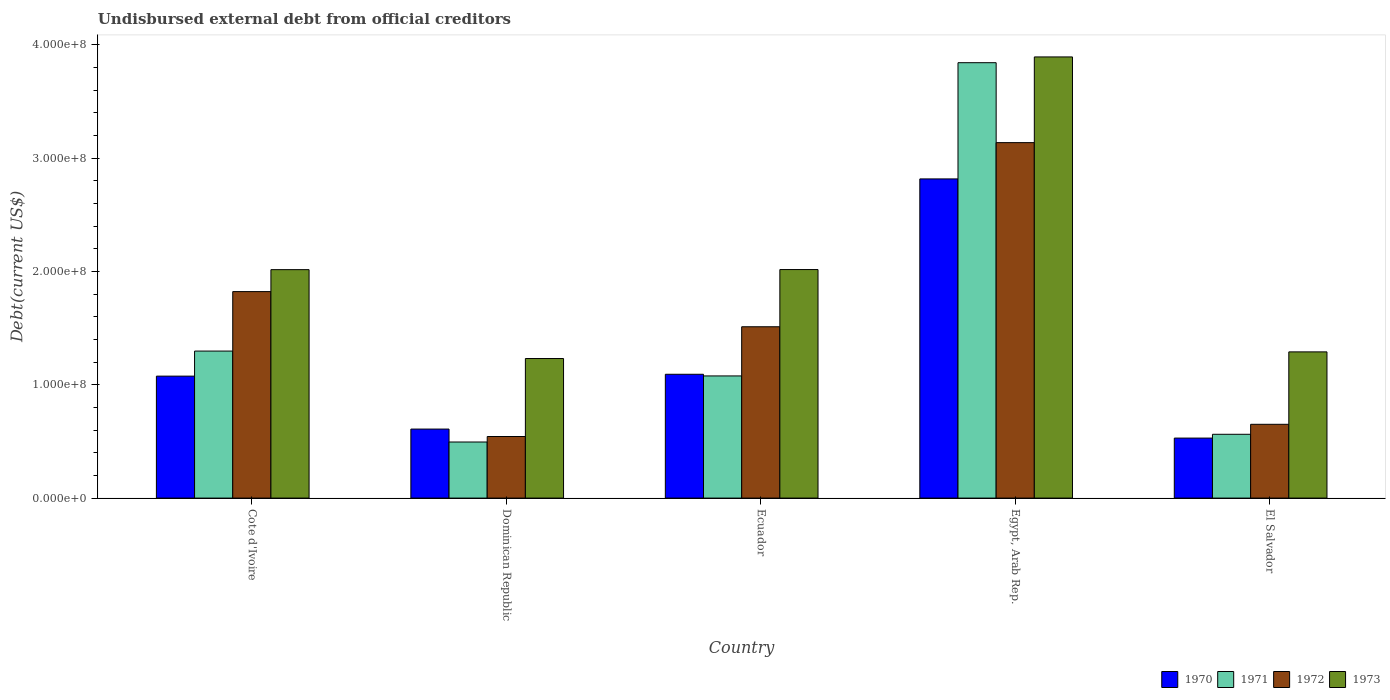Are the number of bars on each tick of the X-axis equal?
Your response must be concise. Yes. How many bars are there on the 4th tick from the left?
Give a very brief answer. 4. What is the label of the 2nd group of bars from the left?
Make the answer very short. Dominican Republic. In how many cases, is the number of bars for a given country not equal to the number of legend labels?
Give a very brief answer. 0. What is the total debt in 1972 in Egypt, Arab Rep.?
Keep it short and to the point. 3.14e+08. Across all countries, what is the maximum total debt in 1970?
Provide a succinct answer. 2.82e+08. Across all countries, what is the minimum total debt in 1972?
Ensure brevity in your answer.  5.44e+07. In which country was the total debt in 1973 maximum?
Provide a succinct answer. Egypt, Arab Rep. In which country was the total debt in 1970 minimum?
Offer a very short reply. El Salvador. What is the total total debt in 1972 in the graph?
Make the answer very short. 7.67e+08. What is the difference between the total debt in 1972 in Dominican Republic and that in Ecuador?
Offer a very short reply. -9.69e+07. What is the difference between the total debt in 1972 in Dominican Republic and the total debt in 1971 in Ecuador?
Give a very brief answer. -5.35e+07. What is the average total debt in 1973 per country?
Provide a short and direct response. 2.09e+08. What is the difference between the total debt of/in 1972 and total debt of/in 1973 in Ecuador?
Offer a terse response. -5.05e+07. In how many countries, is the total debt in 1972 greater than 300000000 US$?
Offer a terse response. 1. What is the ratio of the total debt in 1971 in Ecuador to that in El Salvador?
Offer a terse response. 1.91. Is the difference between the total debt in 1972 in Cote d'Ivoire and El Salvador greater than the difference between the total debt in 1973 in Cote d'Ivoire and El Salvador?
Offer a terse response. Yes. What is the difference between the highest and the second highest total debt in 1972?
Make the answer very short. 1.63e+08. What is the difference between the highest and the lowest total debt in 1973?
Your answer should be compact. 2.66e+08. Is the sum of the total debt in 1972 in Ecuador and El Salvador greater than the maximum total debt in 1970 across all countries?
Offer a very short reply. No. What does the 1st bar from the right in Egypt, Arab Rep. represents?
Provide a short and direct response. 1973. How many bars are there?
Your response must be concise. 20. Are the values on the major ticks of Y-axis written in scientific E-notation?
Ensure brevity in your answer.  Yes. Does the graph contain grids?
Your answer should be very brief. No. Where does the legend appear in the graph?
Offer a terse response. Bottom right. How many legend labels are there?
Offer a terse response. 4. What is the title of the graph?
Ensure brevity in your answer.  Undisbursed external debt from official creditors. What is the label or title of the X-axis?
Your answer should be very brief. Country. What is the label or title of the Y-axis?
Keep it short and to the point. Debt(current US$). What is the Debt(current US$) of 1970 in Cote d'Ivoire?
Offer a terse response. 1.08e+08. What is the Debt(current US$) of 1971 in Cote d'Ivoire?
Your response must be concise. 1.30e+08. What is the Debt(current US$) of 1972 in Cote d'Ivoire?
Your answer should be compact. 1.82e+08. What is the Debt(current US$) of 1973 in Cote d'Ivoire?
Offer a terse response. 2.02e+08. What is the Debt(current US$) of 1970 in Dominican Republic?
Provide a succinct answer. 6.09e+07. What is the Debt(current US$) in 1971 in Dominican Republic?
Your answer should be compact. 4.95e+07. What is the Debt(current US$) in 1972 in Dominican Republic?
Ensure brevity in your answer.  5.44e+07. What is the Debt(current US$) of 1973 in Dominican Republic?
Offer a very short reply. 1.23e+08. What is the Debt(current US$) of 1970 in Ecuador?
Offer a very short reply. 1.09e+08. What is the Debt(current US$) of 1971 in Ecuador?
Offer a terse response. 1.08e+08. What is the Debt(current US$) of 1972 in Ecuador?
Make the answer very short. 1.51e+08. What is the Debt(current US$) in 1973 in Ecuador?
Your answer should be compact. 2.02e+08. What is the Debt(current US$) in 1970 in Egypt, Arab Rep.?
Provide a succinct answer. 2.82e+08. What is the Debt(current US$) of 1971 in Egypt, Arab Rep.?
Give a very brief answer. 3.84e+08. What is the Debt(current US$) in 1972 in Egypt, Arab Rep.?
Ensure brevity in your answer.  3.14e+08. What is the Debt(current US$) in 1973 in Egypt, Arab Rep.?
Provide a short and direct response. 3.89e+08. What is the Debt(current US$) in 1970 in El Salvador?
Your answer should be very brief. 5.30e+07. What is the Debt(current US$) in 1971 in El Salvador?
Offer a terse response. 5.63e+07. What is the Debt(current US$) of 1972 in El Salvador?
Offer a very short reply. 6.51e+07. What is the Debt(current US$) of 1973 in El Salvador?
Provide a succinct answer. 1.29e+08. Across all countries, what is the maximum Debt(current US$) in 1970?
Your answer should be very brief. 2.82e+08. Across all countries, what is the maximum Debt(current US$) of 1971?
Ensure brevity in your answer.  3.84e+08. Across all countries, what is the maximum Debt(current US$) of 1972?
Offer a very short reply. 3.14e+08. Across all countries, what is the maximum Debt(current US$) in 1973?
Your answer should be compact. 3.89e+08. Across all countries, what is the minimum Debt(current US$) in 1970?
Your answer should be compact. 5.30e+07. Across all countries, what is the minimum Debt(current US$) in 1971?
Give a very brief answer. 4.95e+07. Across all countries, what is the minimum Debt(current US$) in 1972?
Ensure brevity in your answer.  5.44e+07. Across all countries, what is the minimum Debt(current US$) of 1973?
Your answer should be compact. 1.23e+08. What is the total Debt(current US$) of 1970 in the graph?
Make the answer very short. 6.13e+08. What is the total Debt(current US$) in 1971 in the graph?
Make the answer very short. 7.28e+08. What is the total Debt(current US$) in 1972 in the graph?
Your answer should be compact. 7.67e+08. What is the total Debt(current US$) in 1973 in the graph?
Your answer should be compact. 1.05e+09. What is the difference between the Debt(current US$) in 1970 in Cote d'Ivoire and that in Dominican Republic?
Provide a short and direct response. 4.67e+07. What is the difference between the Debt(current US$) in 1971 in Cote d'Ivoire and that in Dominican Republic?
Provide a succinct answer. 8.03e+07. What is the difference between the Debt(current US$) in 1972 in Cote d'Ivoire and that in Dominican Republic?
Offer a very short reply. 1.28e+08. What is the difference between the Debt(current US$) of 1973 in Cote d'Ivoire and that in Dominican Republic?
Ensure brevity in your answer.  7.84e+07. What is the difference between the Debt(current US$) of 1970 in Cote d'Ivoire and that in Ecuador?
Keep it short and to the point. -1.64e+06. What is the difference between the Debt(current US$) in 1971 in Cote d'Ivoire and that in Ecuador?
Your answer should be very brief. 2.19e+07. What is the difference between the Debt(current US$) in 1972 in Cote d'Ivoire and that in Ecuador?
Your answer should be very brief. 3.10e+07. What is the difference between the Debt(current US$) of 1973 in Cote d'Ivoire and that in Ecuador?
Provide a succinct answer. -8.40e+04. What is the difference between the Debt(current US$) of 1970 in Cote d'Ivoire and that in Egypt, Arab Rep.?
Your answer should be very brief. -1.74e+08. What is the difference between the Debt(current US$) of 1971 in Cote d'Ivoire and that in Egypt, Arab Rep.?
Your answer should be compact. -2.55e+08. What is the difference between the Debt(current US$) of 1972 in Cote d'Ivoire and that in Egypt, Arab Rep.?
Offer a very short reply. -1.31e+08. What is the difference between the Debt(current US$) in 1973 in Cote d'Ivoire and that in Egypt, Arab Rep.?
Your answer should be compact. -1.88e+08. What is the difference between the Debt(current US$) of 1970 in Cote d'Ivoire and that in El Salvador?
Your answer should be compact. 5.47e+07. What is the difference between the Debt(current US$) in 1971 in Cote d'Ivoire and that in El Salvador?
Offer a terse response. 7.35e+07. What is the difference between the Debt(current US$) in 1972 in Cote d'Ivoire and that in El Salvador?
Provide a succinct answer. 1.17e+08. What is the difference between the Debt(current US$) in 1973 in Cote d'Ivoire and that in El Salvador?
Offer a very short reply. 7.26e+07. What is the difference between the Debt(current US$) in 1970 in Dominican Republic and that in Ecuador?
Provide a succinct answer. -4.84e+07. What is the difference between the Debt(current US$) in 1971 in Dominican Republic and that in Ecuador?
Provide a succinct answer. -5.83e+07. What is the difference between the Debt(current US$) of 1972 in Dominican Republic and that in Ecuador?
Offer a very short reply. -9.69e+07. What is the difference between the Debt(current US$) in 1973 in Dominican Republic and that in Ecuador?
Offer a very short reply. -7.85e+07. What is the difference between the Debt(current US$) in 1970 in Dominican Republic and that in Egypt, Arab Rep.?
Provide a succinct answer. -2.21e+08. What is the difference between the Debt(current US$) of 1971 in Dominican Republic and that in Egypt, Arab Rep.?
Offer a very short reply. -3.35e+08. What is the difference between the Debt(current US$) of 1972 in Dominican Republic and that in Egypt, Arab Rep.?
Your answer should be compact. -2.59e+08. What is the difference between the Debt(current US$) of 1973 in Dominican Republic and that in Egypt, Arab Rep.?
Ensure brevity in your answer.  -2.66e+08. What is the difference between the Debt(current US$) in 1970 in Dominican Republic and that in El Salvador?
Your answer should be compact. 7.96e+06. What is the difference between the Debt(current US$) of 1971 in Dominican Republic and that in El Salvador?
Provide a short and direct response. -6.81e+06. What is the difference between the Debt(current US$) of 1972 in Dominican Republic and that in El Salvador?
Offer a terse response. -1.08e+07. What is the difference between the Debt(current US$) of 1973 in Dominican Republic and that in El Salvador?
Ensure brevity in your answer.  -5.85e+06. What is the difference between the Debt(current US$) of 1970 in Ecuador and that in Egypt, Arab Rep.?
Keep it short and to the point. -1.72e+08. What is the difference between the Debt(current US$) in 1971 in Ecuador and that in Egypt, Arab Rep.?
Offer a very short reply. -2.76e+08. What is the difference between the Debt(current US$) in 1972 in Ecuador and that in Egypt, Arab Rep.?
Your answer should be compact. -1.63e+08. What is the difference between the Debt(current US$) in 1973 in Ecuador and that in Egypt, Arab Rep.?
Keep it short and to the point. -1.88e+08. What is the difference between the Debt(current US$) of 1970 in Ecuador and that in El Salvador?
Offer a very short reply. 5.63e+07. What is the difference between the Debt(current US$) of 1971 in Ecuador and that in El Salvador?
Offer a terse response. 5.15e+07. What is the difference between the Debt(current US$) in 1972 in Ecuador and that in El Salvador?
Provide a short and direct response. 8.61e+07. What is the difference between the Debt(current US$) of 1973 in Ecuador and that in El Salvador?
Ensure brevity in your answer.  7.27e+07. What is the difference between the Debt(current US$) in 1970 in Egypt, Arab Rep. and that in El Salvador?
Your response must be concise. 2.29e+08. What is the difference between the Debt(current US$) of 1971 in Egypt, Arab Rep. and that in El Salvador?
Provide a succinct answer. 3.28e+08. What is the difference between the Debt(current US$) in 1972 in Egypt, Arab Rep. and that in El Salvador?
Your response must be concise. 2.49e+08. What is the difference between the Debt(current US$) of 1973 in Egypt, Arab Rep. and that in El Salvador?
Offer a terse response. 2.60e+08. What is the difference between the Debt(current US$) in 1970 in Cote d'Ivoire and the Debt(current US$) in 1971 in Dominican Republic?
Your response must be concise. 5.81e+07. What is the difference between the Debt(current US$) of 1970 in Cote d'Ivoire and the Debt(current US$) of 1972 in Dominican Republic?
Provide a succinct answer. 5.33e+07. What is the difference between the Debt(current US$) of 1970 in Cote d'Ivoire and the Debt(current US$) of 1973 in Dominican Republic?
Provide a succinct answer. -1.55e+07. What is the difference between the Debt(current US$) of 1971 in Cote d'Ivoire and the Debt(current US$) of 1972 in Dominican Republic?
Your response must be concise. 7.54e+07. What is the difference between the Debt(current US$) of 1971 in Cote d'Ivoire and the Debt(current US$) of 1973 in Dominican Republic?
Keep it short and to the point. 6.57e+06. What is the difference between the Debt(current US$) in 1972 in Cote d'Ivoire and the Debt(current US$) in 1973 in Dominican Republic?
Offer a very short reply. 5.91e+07. What is the difference between the Debt(current US$) in 1970 in Cote d'Ivoire and the Debt(current US$) in 1971 in Ecuador?
Give a very brief answer. -1.73e+05. What is the difference between the Debt(current US$) in 1970 in Cote d'Ivoire and the Debt(current US$) in 1972 in Ecuador?
Your answer should be very brief. -4.36e+07. What is the difference between the Debt(current US$) in 1970 in Cote d'Ivoire and the Debt(current US$) in 1973 in Ecuador?
Give a very brief answer. -9.41e+07. What is the difference between the Debt(current US$) in 1971 in Cote d'Ivoire and the Debt(current US$) in 1972 in Ecuador?
Offer a terse response. -2.15e+07. What is the difference between the Debt(current US$) in 1971 in Cote d'Ivoire and the Debt(current US$) in 1973 in Ecuador?
Ensure brevity in your answer.  -7.20e+07. What is the difference between the Debt(current US$) in 1972 in Cote d'Ivoire and the Debt(current US$) in 1973 in Ecuador?
Your answer should be compact. -1.95e+07. What is the difference between the Debt(current US$) of 1970 in Cote d'Ivoire and the Debt(current US$) of 1971 in Egypt, Arab Rep.?
Your response must be concise. -2.77e+08. What is the difference between the Debt(current US$) of 1970 in Cote d'Ivoire and the Debt(current US$) of 1972 in Egypt, Arab Rep.?
Your answer should be very brief. -2.06e+08. What is the difference between the Debt(current US$) of 1970 in Cote d'Ivoire and the Debt(current US$) of 1973 in Egypt, Arab Rep.?
Give a very brief answer. -2.82e+08. What is the difference between the Debt(current US$) in 1971 in Cote d'Ivoire and the Debt(current US$) in 1972 in Egypt, Arab Rep.?
Provide a succinct answer. -1.84e+08. What is the difference between the Debt(current US$) of 1971 in Cote d'Ivoire and the Debt(current US$) of 1973 in Egypt, Arab Rep.?
Your response must be concise. -2.60e+08. What is the difference between the Debt(current US$) of 1972 in Cote d'Ivoire and the Debt(current US$) of 1973 in Egypt, Arab Rep.?
Offer a very short reply. -2.07e+08. What is the difference between the Debt(current US$) in 1970 in Cote d'Ivoire and the Debt(current US$) in 1971 in El Salvador?
Ensure brevity in your answer.  5.13e+07. What is the difference between the Debt(current US$) of 1970 in Cote d'Ivoire and the Debt(current US$) of 1972 in El Salvador?
Your response must be concise. 4.25e+07. What is the difference between the Debt(current US$) in 1970 in Cote d'Ivoire and the Debt(current US$) in 1973 in El Salvador?
Make the answer very short. -2.14e+07. What is the difference between the Debt(current US$) in 1971 in Cote d'Ivoire and the Debt(current US$) in 1972 in El Salvador?
Provide a succinct answer. 6.46e+07. What is the difference between the Debt(current US$) of 1971 in Cote d'Ivoire and the Debt(current US$) of 1973 in El Salvador?
Your answer should be compact. 7.17e+05. What is the difference between the Debt(current US$) of 1972 in Cote d'Ivoire and the Debt(current US$) of 1973 in El Salvador?
Ensure brevity in your answer.  5.32e+07. What is the difference between the Debt(current US$) in 1970 in Dominican Republic and the Debt(current US$) in 1971 in Ecuador?
Your answer should be compact. -4.69e+07. What is the difference between the Debt(current US$) in 1970 in Dominican Republic and the Debt(current US$) in 1972 in Ecuador?
Provide a short and direct response. -9.03e+07. What is the difference between the Debt(current US$) in 1970 in Dominican Republic and the Debt(current US$) in 1973 in Ecuador?
Your answer should be very brief. -1.41e+08. What is the difference between the Debt(current US$) of 1971 in Dominican Republic and the Debt(current US$) of 1972 in Ecuador?
Your answer should be compact. -1.02e+08. What is the difference between the Debt(current US$) in 1971 in Dominican Republic and the Debt(current US$) in 1973 in Ecuador?
Offer a very short reply. -1.52e+08. What is the difference between the Debt(current US$) in 1972 in Dominican Republic and the Debt(current US$) in 1973 in Ecuador?
Ensure brevity in your answer.  -1.47e+08. What is the difference between the Debt(current US$) in 1970 in Dominican Republic and the Debt(current US$) in 1971 in Egypt, Arab Rep.?
Your response must be concise. -3.23e+08. What is the difference between the Debt(current US$) of 1970 in Dominican Republic and the Debt(current US$) of 1972 in Egypt, Arab Rep.?
Provide a short and direct response. -2.53e+08. What is the difference between the Debt(current US$) in 1970 in Dominican Republic and the Debt(current US$) in 1973 in Egypt, Arab Rep.?
Your response must be concise. -3.28e+08. What is the difference between the Debt(current US$) of 1971 in Dominican Republic and the Debt(current US$) of 1972 in Egypt, Arab Rep.?
Provide a short and direct response. -2.64e+08. What is the difference between the Debt(current US$) of 1971 in Dominican Republic and the Debt(current US$) of 1973 in Egypt, Arab Rep.?
Your answer should be very brief. -3.40e+08. What is the difference between the Debt(current US$) of 1972 in Dominican Republic and the Debt(current US$) of 1973 in Egypt, Arab Rep.?
Keep it short and to the point. -3.35e+08. What is the difference between the Debt(current US$) of 1970 in Dominican Republic and the Debt(current US$) of 1971 in El Salvador?
Provide a succinct answer. 4.62e+06. What is the difference between the Debt(current US$) in 1970 in Dominican Republic and the Debt(current US$) in 1972 in El Salvador?
Make the answer very short. -4.20e+06. What is the difference between the Debt(current US$) of 1970 in Dominican Republic and the Debt(current US$) of 1973 in El Salvador?
Provide a succinct answer. -6.81e+07. What is the difference between the Debt(current US$) in 1971 in Dominican Republic and the Debt(current US$) in 1972 in El Salvador?
Your answer should be very brief. -1.56e+07. What is the difference between the Debt(current US$) in 1971 in Dominican Republic and the Debt(current US$) in 1973 in El Salvador?
Your response must be concise. -7.95e+07. What is the difference between the Debt(current US$) in 1972 in Dominican Republic and the Debt(current US$) in 1973 in El Salvador?
Offer a terse response. -7.47e+07. What is the difference between the Debt(current US$) of 1970 in Ecuador and the Debt(current US$) of 1971 in Egypt, Arab Rep.?
Ensure brevity in your answer.  -2.75e+08. What is the difference between the Debt(current US$) of 1970 in Ecuador and the Debt(current US$) of 1972 in Egypt, Arab Rep.?
Provide a succinct answer. -2.04e+08. What is the difference between the Debt(current US$) of 1970 in Ecuador and the Debt(current US$) of 1973 in Egypt, Arab Rep.?
Your answer should be compact. -2.80e+08. What is the difference between the Debt(current US$) of 1971 in Ecuador and the Debt(current US$) of 1972 in Egypt, Arab Rep.?
Offer a very short reply. -2.06e+08. What is the difference between the Debt(current US$) in 1971 in Ecuador and the Debt(current US$) in 1973 in Egypt, Arab Rep.?
Offer a terse response. -2.82e+08. What is the difference between the Debt(current US$) in 1972 in Ecuador and the Debt(current US$) in 1973 in Egypt, Arab Rep.?
Offer a terse response. -2.38e+08. What is the difference between the Debt(current US$) of 1970 in Ecuador and the Debt(current US$) of 1971 in El Salvador?
Give a very brief answer. 5.30e+07. What is the difference between the Debt(current US$) in 1970 in Ecuador and the Debt(current US$) in 1972 in El Salvador?
Your answer should be very brief. 4.42e+07. What is the difference between the Debt(current US$) in 1970 in Ecuador and the Debt(current US$) in 1973 in El Salvador?
Keep it short and to the point. -1.98e+07. What is the difference between the Debt(current US$) of 1971 in Ecuador and the Debt(current US$) of 1972 in El Salvador?
Ensure brevity in your answer.  4.27e+07. What is the difference between the Debt(current US$) of 1971 in Ecuador and the Debt(current US$) of 1973 in El Salvador?
Offer a terse response. -2.12e+07. What is the difference between the Debt(current US$) of 1972 in Ecuador and the Debt(current US$) of 1973 in El Salvador?
Make the answer very short. 2.22e+07. What is the difference between the Debt(current US$) of 1970 in Egypt, Arab Rep. and the Debt(current US$) of 1971 in El Salvador?
Keep it short and to the point. 2.25e+08. What is the difference between the Debt(current US$) of 1970 in Egypt, Arab Rep. and the Debt(current US$) of 1972 in El Salvador?
Offer a very short reply. 2.17e+08. What is the difference between the Debt(current US$) of 1970 in Egypt, Arab Rep. and the Debt(current US$) of 1973 in El Salvador?
Provide a succinct answer. 1.53e+08. What is the difference between the Debt(current US$) in 1971 in Egypt, Arab Rep. and the Debt(current US$) in 1972 in El Salvador?
Ensure brevity in your answer.  3.19e+08. What is the difference between the Debt(current US$) in 1971 in Egypt, Arab Rep. and the Debt(current US$) in 1973 in El Salvador?
Offer a very short reply. 2.55e+08. What is the difference between the Debt(current US$) of 1972 in Egypt, Arab Rep. and the Debt(current US$) of 1973 in El Salvador?
Keep it short and to the point. 1.85e+08. What is the average Debt(current US$) in 1970 per country?
Ensure brevity in your answer.  1.23e+08. What is the average Debt(current US$) of 1971 per country?
Make the answer very short. 1.46e+08. What is the average Debt(current US$) in 1972 per country?
Make the answer very short. 1.53e+08. What is the average Debt(current US$) in 1973 per country?
Offer a very short reply. 2.09e+08. What is the difference between the Debt(current US$) in 1970 and Debt(current US$) in 1971 in Cote d'Ivoire?
Ensure brevity in your answer.  -2.21e+07. What is the difference between the Debt(current US$) of 1970 and Debt(current US$) of 1972 in Cote d'Ivoire?
Keep it short and to the point. -7.46e+07. What is the difference between the Debt(current US$) in 1970 and Debt(current US$) in 1973 in Cote d'Ivoire?
Provide a succinct answer. -9.40e+07. What is the difference between the Debt(current US$) in 1971 and Debt(current US$) in 1972 in Cote d'Ivoire?
Provide a short and direct response. -5.25e+07. What is the difference between the Debt(current US$) in 1971 and Debt(current US$) in 1973 in Cote d'Ivoire?
Your response must be concise. -7.19e+07. What is the difference between the Debt(current US$) in 1972 and Debt(current US$) in 1973 in Cote d'Ivoire?
Offer a very short reply. -1.94e+07. What is the difference between the Debt(current US$) in 1970 and Debt(current US$) in 1971 in Dominican Republic?
Give a very brief answer. 1.14e+07. What is the difference between the Debt(current US$) of 1970 and Debt(current US$) of 1972 in Dominican Republic?
Keep it short and to the point. 6.57e+06. What is the difference between the Debt(current US$) of 1970 and Debt(current US$) of 1973 in Dominican Republic?
Your answer should be very brief. -6.23e+07. What is the difference between the Debt(current US$) of 1971 and Debt(current US$) of 1972 in Dominican Republic?
Your answer should be very brief. -4.85e+06. What is the difference between the Debt(current US$) of 1971 and Debt(current US$) of 1973 in Dominican Republic?
Offer a terse response. -7.37e+07. What is the difference between the Debt(current US$) of 1972 and Debt(current US$) of 1973 in Dominican Republic?
Your answer should be compact. -6.88e+07. What is the difference between the Debt(current US$) of 1970 and Debt(current US$) of 1971 in Ecuador?
Your answer should be compact. 1.47e+06. What is the difference between the Debt(current US$) in 1970 and Debt(current US$) in 1972 in Ecuador?
Make the answer very short. -4.19e+07. What is the difference between the Debt(current US$) in 1970 and Debt(current US$) in 1973 in Ecuador?
Provide a succinct answer. -9.24e+07. What is the difference between the Debt(current US$) of 1971 and Debt(current US$) of 1972 in Ecuador?
Your answer should be compact. -4.34e+07. What is the difference between the Debt(current US$) in 1971 and Debt(current US$) in 1973 in Ecuador?
Provide a short and direct response. -9.39e+07. What is the difference between the Debt(current US$) in 1972 and Debt(current US$) in 1973 in Ecuador?
Give a very brief answer. -5.05e+07. What is the difference between the Debt(current US$) of 1970 and Debt(current US$) of 1971 in Egypt, Arab Rep.?
Make the answer very short. -1.03e+08. What is the difference between the Debt(current US$) in 1970 and Debt(current US$) in 1972 in Egypt, Arab Rep.?
Your answer should be very brief. -3.20e+07. What is the difference between the Debt(current US$) of 1970 and Debt(current US$) of 1973 in Egypt, Arab Rep.?
Provide a succinct answer. -1.08e+08. What is the difference between the Debt(current US$) in 1971 and Debt(current US$) in 1972 in Egypt, Arab Rep.?
Your answer should be compact. 7.06e+07. What is the difference between the Debt(current US$) of 1971 and Debt(current US$) of 1973 in Egypt, Arab Rep.?
Keep it short and to the point. -5.09e+06. What is the difference between the Debt(current US$) of 1972 and Debt(current US$) of 1973 in Egypt, Arab Rep.?
Offer a very short reply. -7.56e+07. What is the difference between the Debt(current US$) in 1970 and Debt(current US$) in 1971 in El Salvador?
Your answer should be very brief. -3.35e+06. What is the difference between the Debt(current US$) in 1970 and Debt(current US$) in 1972 in El Salvador?
Your answer should be compact. -1.22e+07. What is the difference between the Debt(current US$) in 1970 and Debt(current US$) in 1973 in El Salvador?
Offer a very short reply. -7.61e+07. What is the difference between the Debt(current US$) in 1971 and Debt(current US$) in 1972 in El Salvador?
Provide a short and direct response. -8.81e+06. What is the difference between the Debt(current US$) in 1971 and Debt(current US$) in 1973 in El Salvador?
Ensure brevity in your answer.  -7.27e+07. What is the difference between the Debt(current US$) of 1972 and Debt(current US$) of 1973 in El Salvador?
Your answer should be very brief. -6.39e+07. What is the ratio of the Debt(current US$) of 1970 in Cote d'Ivoire to that in Dominican Republic?
Give a very brief answer. 1.77. What is the ratio of the Debt(current US$) of 1971 in Cote d'Ivoire to that in Dominican Republic?
Keep it short and to the point. 2.62. What is the ratio of the Debt(current US$) in 1972 in Cote d'Ivoire to that in Dominican Republic?
Your answer should be very brief. 3.35. What is the ratio of the Debt(current US$) of 1973 in Cote d'Ivoire to that in Dominican Republic?
Offer a terse response. 1.64. What is the ratio of the Debt(current US$) of 1970 in Cote d'Ivoire to that in Ecuador?
Your answer should be compact. 0.98. What is the ratio of the Debt(current US$) of 1971 in Cote d'Ivoire to that in Ecuador?
Your answer should be very brief. 1.2. What is the ratio of the Debt(current US$) in 1972 in Cote d'Ivoire to that in Ecuador?
Offer a terse response. 1.21. What is the ratio of the Debt(current US$) of 1973 in Cote d'Ivoire to that in Ecuador?
Provide a succinct answer. 1. What is the ratio of the Debt(current US$) in 1970 in Cote d'Ivoire to that in Egypt, Arab Rep.?
Give a very brief answer. 0.38. What is the ratio of the Debt(current US$) in 1971 in Cote d'Ivoire to that in Egypt, Arab Rep.?
Offer a terse response. 0.34. What is the ratio of the Debt(current US$) in 1972 in Cote d'Ivoire to that in Egypt, Arab Rep.?
Your answer should be compact. 0.58. What is the ratio of the Debt(current US$) in 1973 in Cote d'Ivoire to that in Egypt, Arab Rep.?
Provide a succinct answer. 0.52. What is the ratio of the Debt(current US$) in 1970 in Cote d'Ivoire to that in El Salvador?
Your response must be concise. 2.03. What is the ratio of the Debt(current US$) of 1971 in Cote d'Ivoire to that in El Salvador?
Keep it short and to the point. 2.3. What is the ratio of the Debt(current US$) in 1972 in Cote d'Ivoire to that in El Salvador?
Ensure brevity in your answer.  2.8. What is the ratio of the Debt(current US$) of 1973 in Cote d'Ivoire to that in El Salvador?
Give a very brief answer. 1.56. What is the ratio of the Debt(current US$) of 1970 in Dominican Republic to that in Ecuador?
Give a very brief answer. 0.56. What is the ratio of the Debt(current US$) in 1971 in Dominican Republic to that in Ecuador?
Your answer should be very brief. 0.46. What is the ratio of the Debt(current US$) of 1972 in Dominican Republic to that in Ecuador?
Provide a succinct answer. 0.36. What is the ratio of the Debt(current US$) of 1973 in Dominican Republic to that in Ecuador?
Keep it short and to the point. 0.61. What is the ratio of the Debt(current US$) in 1970 in Dominican Republic to that in Egypt, Arab Rep.?
Your answer should be compact. 0.22. What is the ratio of the Debt(current US$) of 1971 in Dominican Republic to that in Egypt, Arab Rep.?
Provide a succinct answer. 0.13. What is the ratio of the Debt(current US$) in 1972 in Dominican Republic to that in Egypt, Arab Rep.?
Offer a very short reply. 0.17. What is the ratio of the Debt(current US$) of 1973 in Dominican Republic to that in Egypt, Arab Rep.?
Offer a very short reply. 0.32. What is the ratio of the Debt(current US$) in 1970 in Dominican Republic to that in El Salvador?
Your response must be concise. 1.15. What is the ratio of the Debt(current US$) of 1971 in Dominican Republic to that in El Salvador?
Offer a very short reply. 0.88. What is the ratio of the Debt(current US$) in 1972 in Dominican Republic to that in El Salvador?
Offer a very short reply. 0.83. What is the ratio of the Debt(current US$) of 1973 in Dominican Republic to that in El Salvador?
Your response must be concise. 0.95. What is the ratio of the Debt(current US$) of 1970 in Ecuador to that in Egypt, Arab Rep.?
Your answer should be very brief. 0.39. What is the ratio of the Debt(current US$) of 1971 in Ecuador to that in Egypt, Arab Rep.?
Your answer should be very brief. 0.28. What is the ratio of the Debt(current US$) of 1972 in Ecuador to that in Egypt, Arab Rep.?
Your answer should be very brief. 0.48. What is the ratio of the Debt(current US$) in 1973 in Ecuador to that in Egypt, Arab Rep.?
Provide a succinct answer. 0.52. What is the ratio of the Debt(current US$) in 1970 in Ecuador to that in El Salvador?
Offer a very short reply. 2.06. What is the ratio of the Debt(current US$) of 1971 in Ecuador to that in El Salvador?
Give a very brief answer. 1.91. What is the ratio of the Debt(current US$) of 1972 in Ecuador to that in El Salvador?
Provide a succinct answer. 2.32. What is the ratio of the Debt(current US$) in 1973 in Ecuador to that in El Salvador?
Ensure brevity in your answer.  1.56. What is the ratio of the Debt(current US$) of 1970 in Egypt, Arab Rep. to that in El Salvador?
Offer a terse response. 5.32. What is the ratio of the Debt(current US$) of 1971 in Egypt, Arab Rep. to that in El Salvador?
Your response must be concise. 6.82. What is the ratio of the Debt(current US$) of 1972 in Egypt, Arab Rep. to that in El Salvador?
Offer a terse response. 4.82. What is the ratio of the Debt(current US$) of 1973 in Egypt, Arab Rep. to that in El Salvador?
Provide a succinct answer. 3.02. What is the difference between the highest and the second highest Debt(current US$) in 1970?
Make the answer very short. 1.72e+08. What is the difference between the highest and the second highest Debt(current US$) in 1971?
Keep it short and to the point. 2.55e+08. What is the difference between the highest and the second highest Debt(current US$) of 1972?
Keep it short and to the point. 1.31e+08. What is the difference between the highest and the second highest Debt(current US$) in 1973?
Your response must be concise. 1.88e+08. What is the difference between the highest and the lowest Debt(current US$) of 1970?
Make the answer very short. 2.29e+08. What is the difference between the highest and the lowest Debt(current US$) in 1971?
Your answer should be compact. 3.35e+08. What is the difference between the highest and the lowest Debt(current US$) of 1972?
Ensure brevity in your answer.  2.59e+08. What is the difference between the highest and the lowest Debt(current US$) in 1973?
Give a very brief answer. 2.66e+08. 